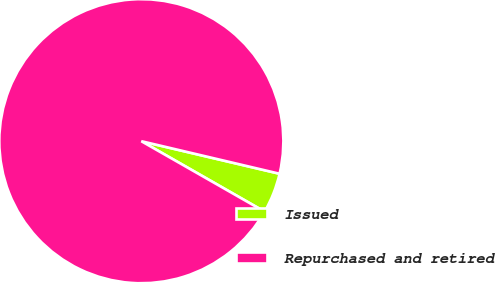<chart> <loc_0><loc_0><loc_500><loc_500><pie_chart><fcel>Issued<fcel>Repurchased and retired<nl><fcel>4.58%<fcel>95.42%<nl></chart> 